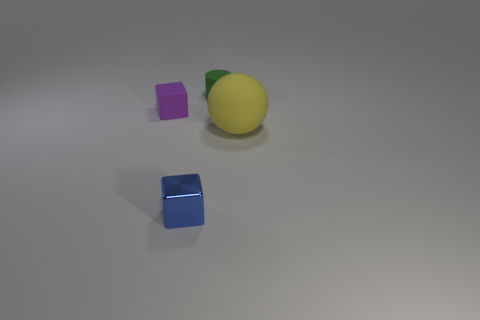What number of things are either purple cubes or small cubes on the left side of the shiny thing? Upon careful observation of the image, we can identify two cubes: one purple and another one that is blue. The purple cube, by its apparent size and color, fits the description of being a purple cube. However, there is no small cube on the left side of the shiny yellow spherical object. Therefore, the total count of things that are either purple cubes or small cubes on the specified side of the shiny object is one. 